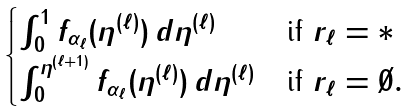<formula> <loc_0><loc_0><loc_500><loc_500>\begin{cases} \int _ { 0 } ^ { 1 } f _ { \alpha _ { \ell } } ( \eta ^ { ( \ell ) } ) \, d \eta ^ { ( \ell ) } & \text {if } r _ { \ell } = \ast \\ \int _ { 0 } ^ { \eta ^ { ( \ell + 1 ) } } f _ { \alpha _ { \ell } } ( \eta ^ { ( \ell ) } ) \, d \eta ^ { ( \ell ) } & \text {if } r _ { \ell } = \emptyset . \end{cases}</formula> 